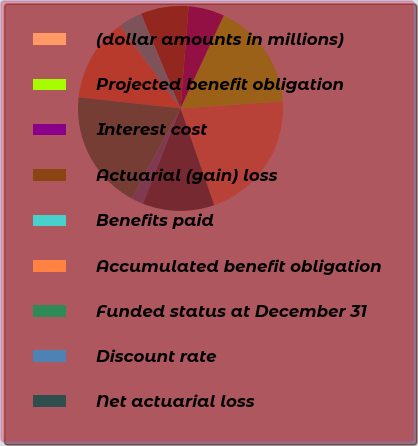Convert chart to OTSL. <chart><loc_0><loc_0><loc_500><loc_500><pie_chart><fcel>(dollar amounts in millions)<fcel>Projected benefit obligation<fcel>Interest cost<fcel>Actuarial (gain) loss<fcel>Benefits paid<fcel>Accumulated benefit obligation<fcel>Funded status at December 31<fcel>Discount rate<fcel>Net actuarial loss<nl><fcel>20.74%<fcel>16.97%<fcel>5.67%<fcel>7.55%<fcel>3.79%<fcel>13.2%<fcel>18.85%<fcel>1.9%<fcel>11.32%<nl></chart> 